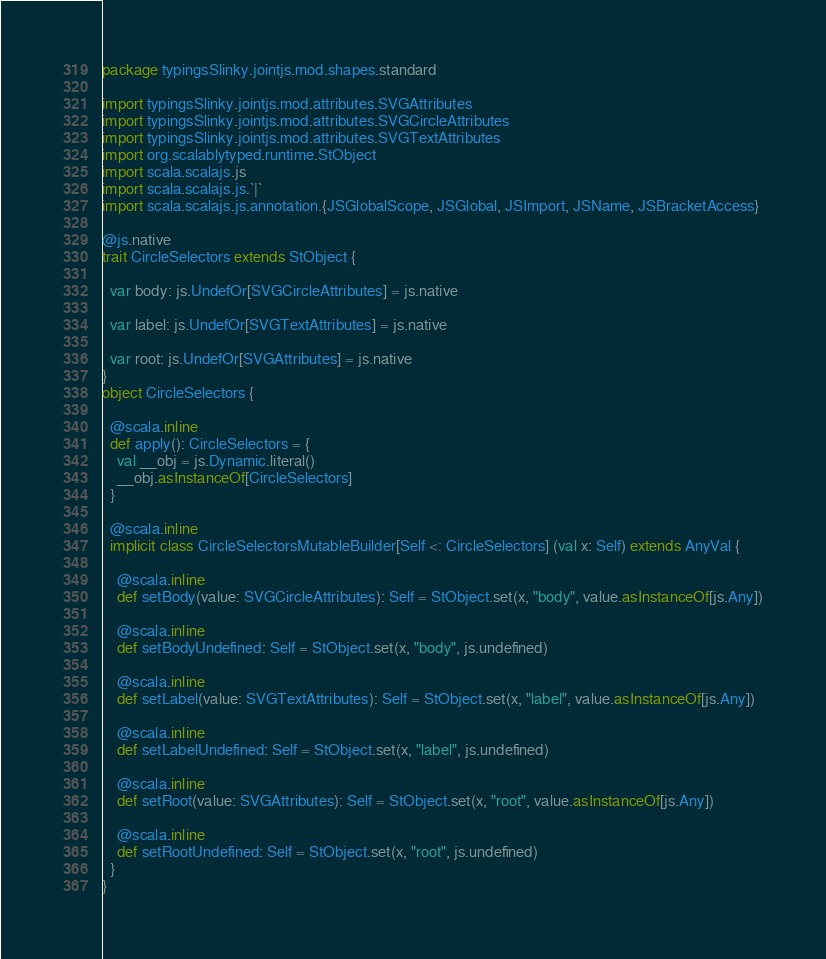<code> <loc_0><loc_0><loc_500><loc_500><_Scala_>package typingsSlinky.jointjs.mod.shapes.standard

import typingsSlinky.jointjs.mod.attributes.SVGAttributes
import typingsSlinky.jointjs.mod.attributes.SVGCircleAttributes
import typingsSlinky.jointjs.mod.attributes.SVGTextAttributes
import org.scalablytyped.runtime.StObject
import scala.scalajs.js
import scala.scalajs.js.`|`
import scala.scalajs.js.annotation.{JSGlobalScope, JSGlobal, JSImport, JSName, JSBracketAccess}

@js.native
trait CircleSelectors extends StObject {
  
  var body: js.UndefOr[SVGCircleAttributes] = js.native
  
  var label: js.UndefOr[SVGTextAttributes] = js.native
  
  var root: js.UndefOr[SVGAttributes] = js.native
}
object CircleSelectors {
  
  @scala.inline
  def apply(): CircleSelectors = {
    val __obj = js.Dynamic.literal()
    __obj.asInstanceOf[CircleSelectors]
  }
  
  @scala.inline
  implicit class CircleSelectorsMutableBuilder[Self <: CircleSelectors] (val x: Self) extends AnyVal {
    
    @scala.inline
    def setBody(value: SVGCircleAttributes): Self = StObject.set(x, "body", value.asInstanceOf[js.Any])
    
    @scala.inline
    def setBodyUndefined: Self = StObject.set(x, "body", js.undefined)
    
    @scala.inline
    def setLabel(value: SVGTextAttributes): Self = StObject.set(x, "label", value.asInstanceOf[js.Any])
    
    @scala.inline
    def setLabelUndefined: Self = StObject.set(x, "label", js.undefined)
    
    @scala.inline
    def setRoot(value: SVGAttributes): Self = StObject.set(x, "root", value.asInstanceOf[js.Any])
    
    @scala.inline
    def setRootUndefined: Self = StObject.set(x, "root", js.undefined)
  }
}
</code> 